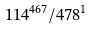Convert formula to latex. <formula><loc_0><loc_0><loc_500><loc_500>1 1 4 ^ { 4 6 7 } / 4 7 8 ^ { 1 }</formula> 